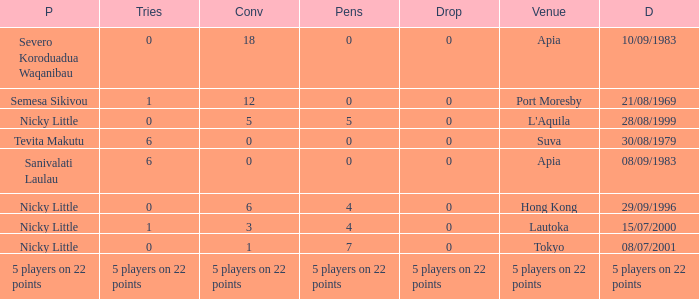How many conversions did Severo Koroduadua Waqanibau have when he has 0 pens? 18.0. 